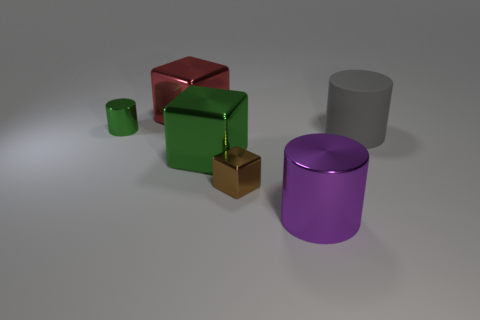Add 4 large gray matte cylinders. How many objects exist? 10 Subtract 0 gray cubes. How many objects are left? 6 Subtract all shiny blocks. Subtract all red blocks. How many objects are left? 2 Add 1 brown metal blocks. How many brown metal blocks are left? 2 Add 4 red matte things. How many red matte things exist? 4 